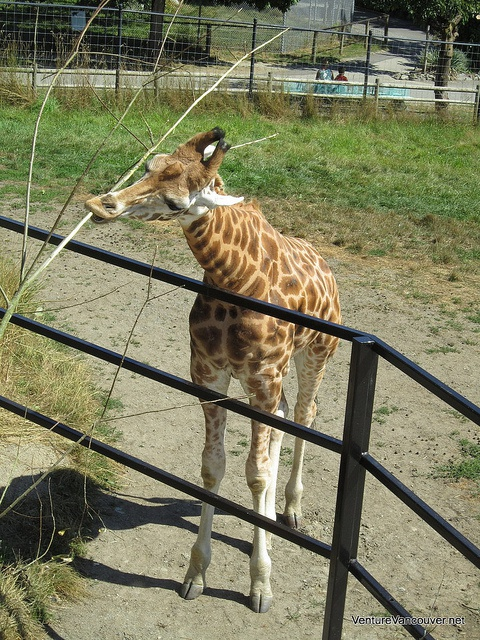Describe the objects in this image and their specific colors. I can see giraffe in darkgreen, black, gray, and tan tones, people in darkgreen, black, gray, and darkgray tones, and people in darkgreen, black, maroon, gray, and darkgray tones in this image. 